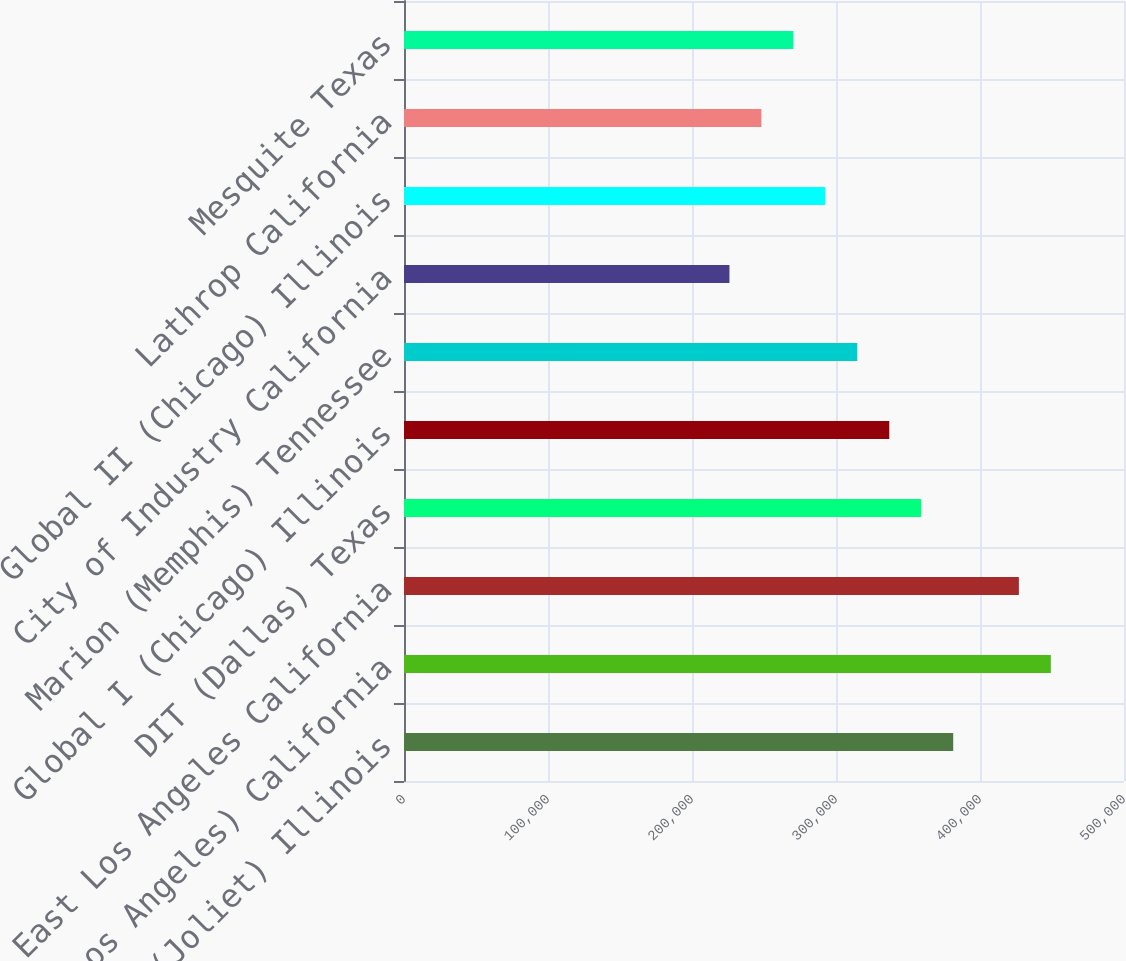Convert chart. <chart><loc_0><loc_0><loc_500><loc_500><bar_chart><fcel>Global IV (Joliet) Illinois<fcel>ICTF (Los Angeles) California<fcel>East Los Angeles California<fcel>DIT (Dallas) Texas<fcel>Global I (Chicago) Illinois<fcel>Marion (Memphis) Tennessee<fcel>City of Industry California<fcel>Global II (Chicago) Illinois<fcel>Lathrop California<fcel>Mesquite Texas<nl><fcel>381400<fcel>449200<fcel>427000<fcel>359200<fcel>337000<fcel>314800<fcel>226000<fcel>292600<fcel>248200<fcel>270400<nl></chart> 